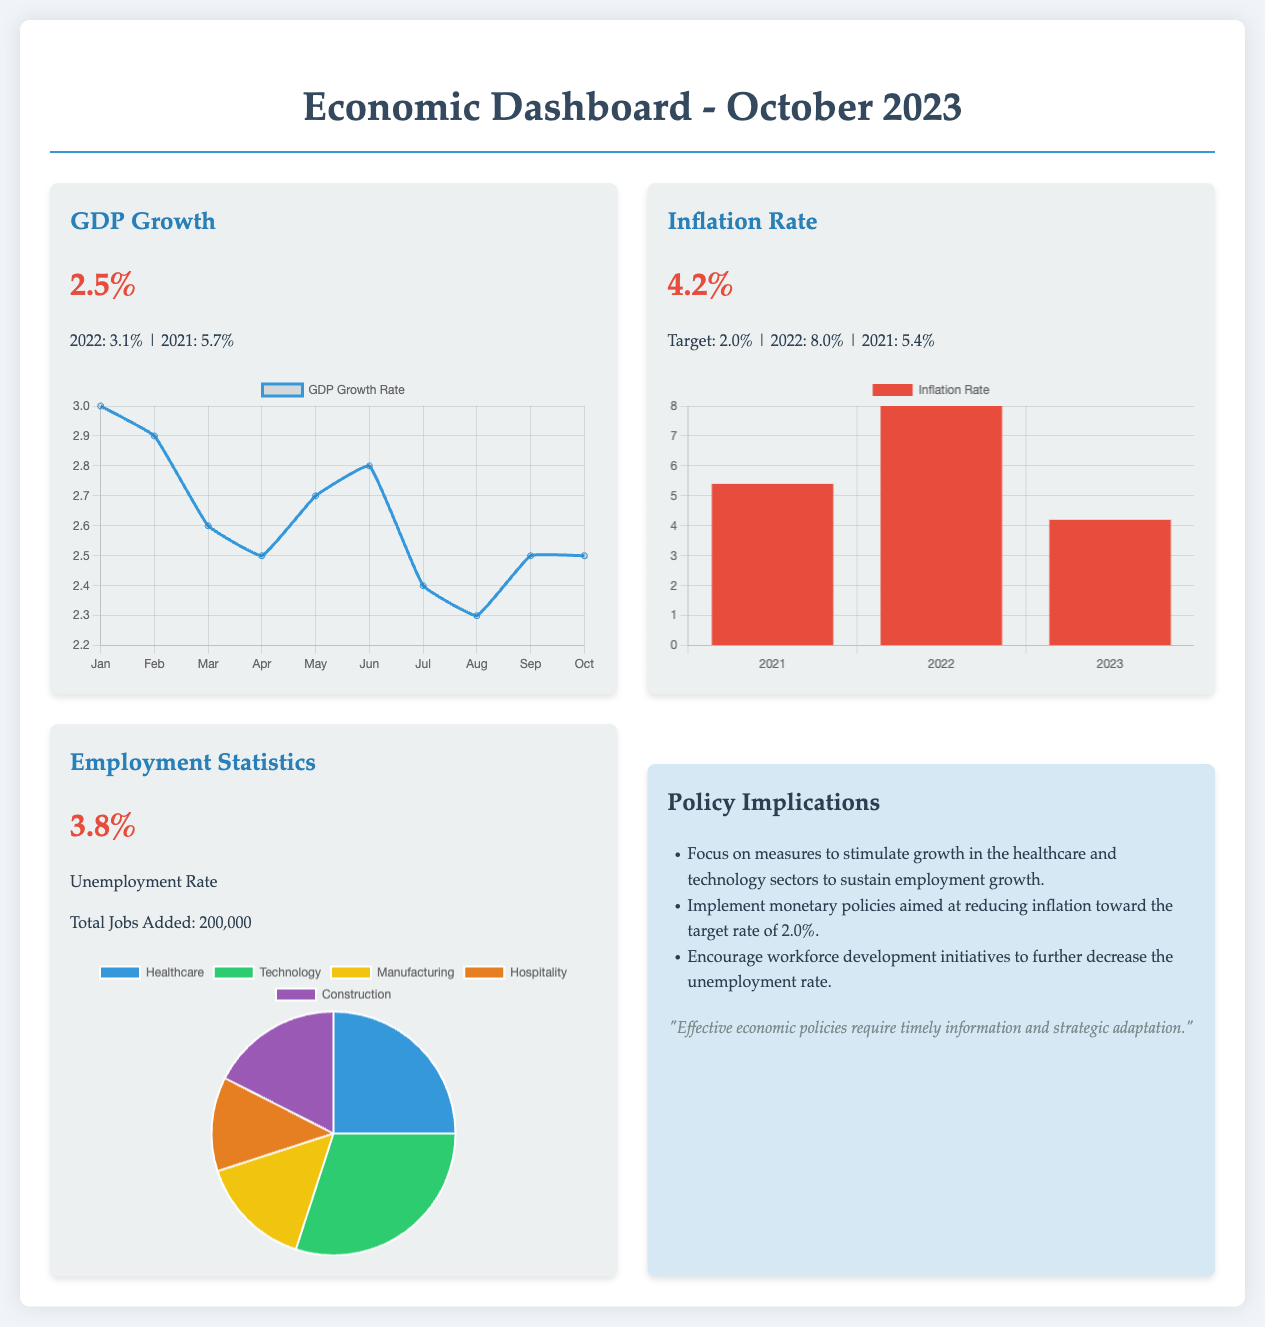What is the GDP growth rate? The GDP growth rate is stated as 2.5% in the dashboard.
Answer: 2.5% What was the unemployment rate? The unemployment rate is presented as 3.8% in the employment statistics section.
Answer: 3.8% What was the inflation rate in 2022? The inflation rate for 2022 is noted as 8.0%.
Answer: 8.0% How many total jobs were added? The total jobs added is provided as 200,000 in the statistics.
Answer: 200,000 What are the primary sectors mentioned for employment growth? The sectors mentioned for employment growth are healthcare and technology.
Answer: Healthcare and technology What is the target inflation rate? The target inflation rate is mentioned as 2.0% in the dashboard.
Answer: 2.0% Which chart type is used for showing GDP growth? The chart type used for GDP growth is a line chart.
Answer: Line chart What does the document suggest to reduce inflation? The document suggests implementing monetary policies to reduce inflation.
Answer: Implement monetary policies Which year shows the highest inflation rate in the bar chart? The year that shows the highest inflation rate in the chart is 2022.
Answer: 2022 